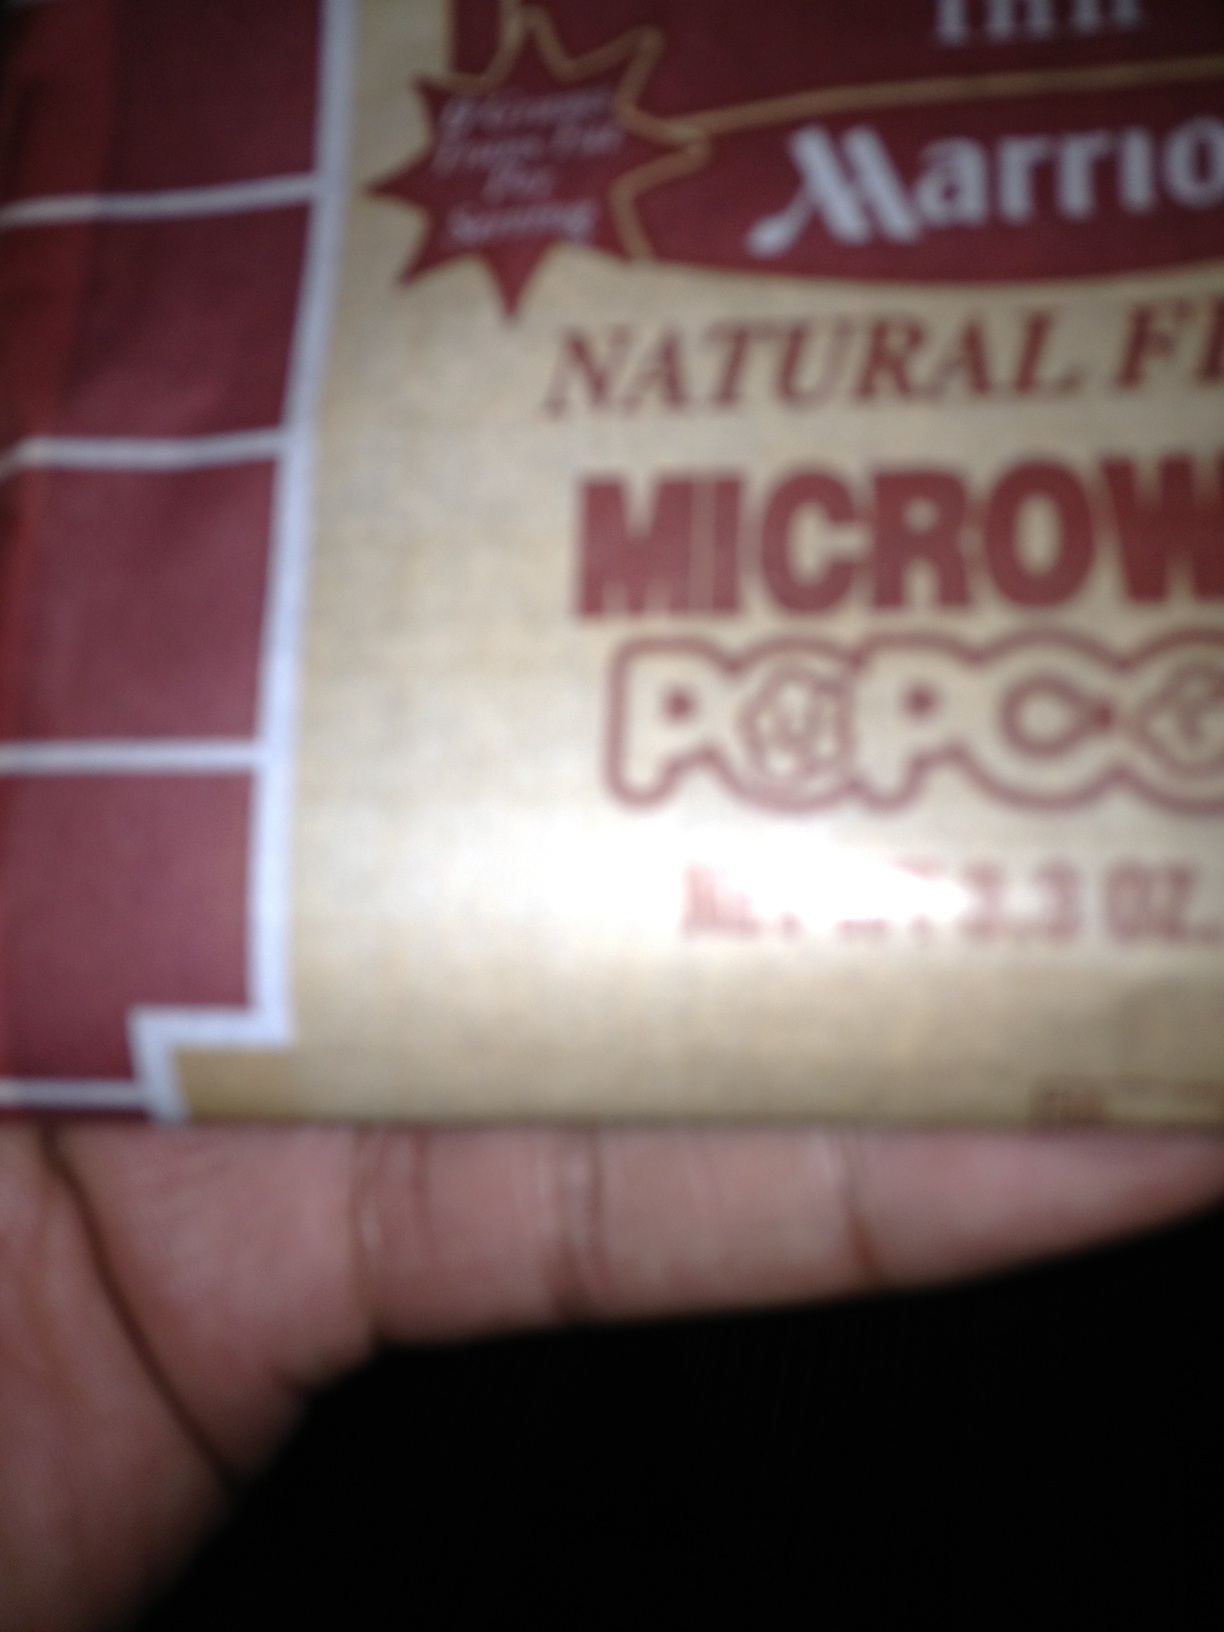Does this type of popcorn require any preparation before eating? Yes, this is microwavable popcorn, which means you'll need to microwave the bag according to the instructions on the packaging before eating. Typically, this involves heating the bag for about 2-3 minutes, but it's important to follow the specific directions to avoid burning the popcorn. What are the typical nutritional values for microwavable popcorn? Microwavable popcorn generally contains calories from fats, carbohydrates, and proteins. A typical serving might have around 150 to 300 calories, with varying amounts of dietary fiber and sodium. It's important to read the nutritional label for specific values as they can significantly differ based on the brand and flavor. 